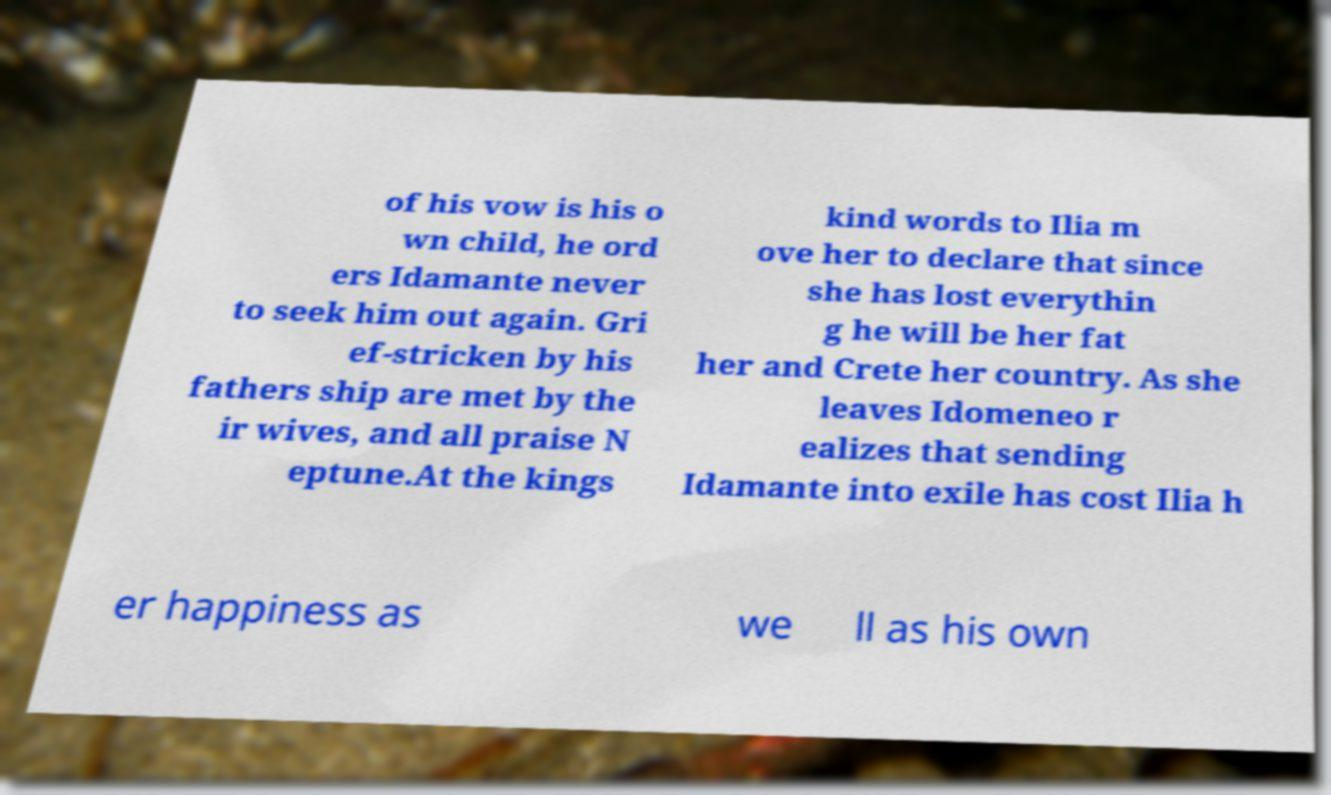Please identify and transcribe the text found in this image. of his vow is his o wn child, he ord ers Idamante never to seek him out again. Gri ef-stricken by his fathers ship are met by the ir wives, and all praise N eptune.At the kings kind words to Ilia m ove her to declare that since she has lost everythin g he will be her fat her and Crete her country. As she leaves Idomeneo r ealizes that sending Idamante into exile has cost Ilia h er happiness as we ll as his own 